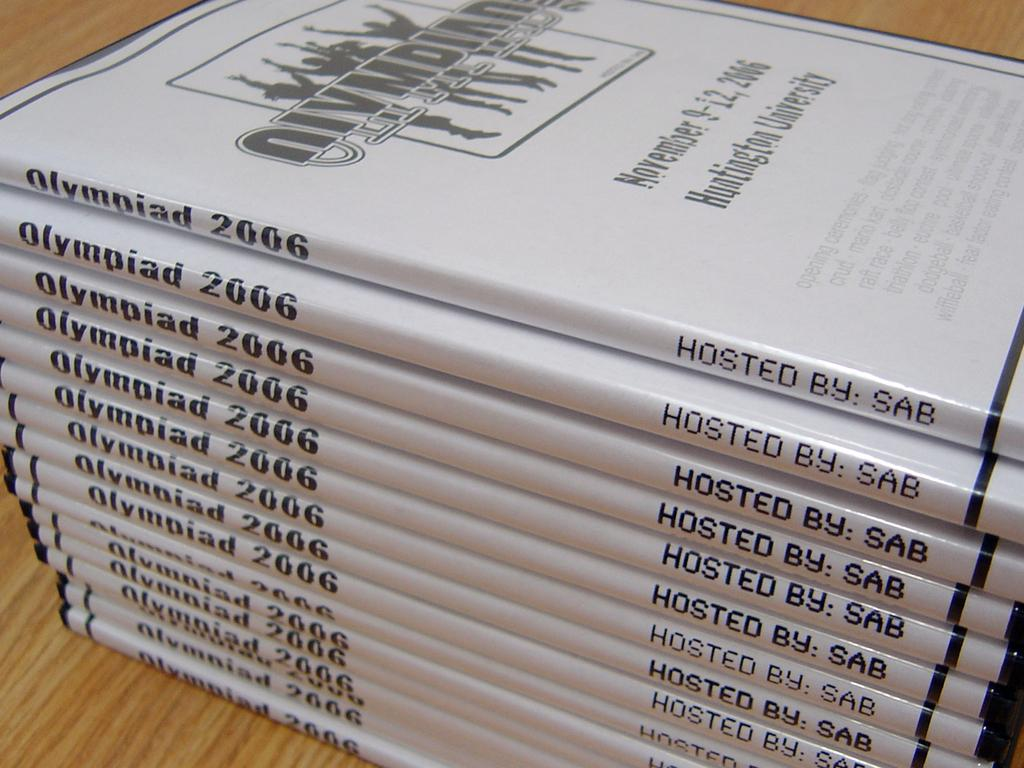<image>
Write a terse but informative summary of the picture. A stack of books are entitled Olympiad 2006 